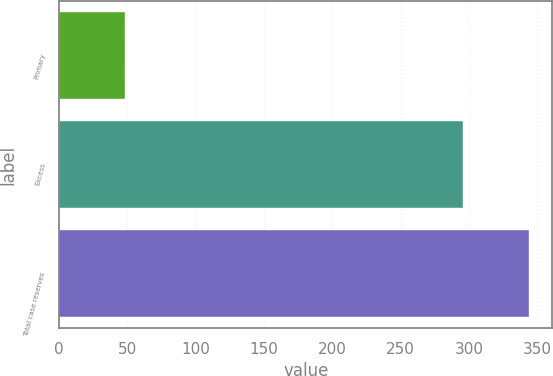<chart> <loc_0><loc_0><loc_500><loc_500><bar_chart><fcel>Primary<fcel>Excess<fcel>Total case reserves<nl><fcel>48<fcel>296<fcel>344<nl></chart> 